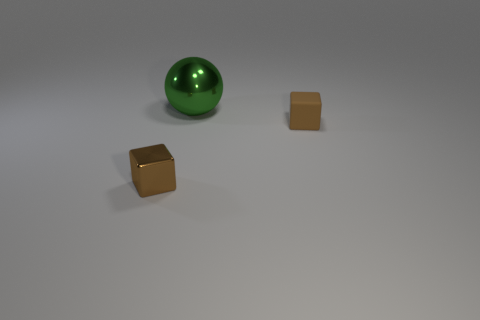Add 1 small rubber blocks. How many objects exist? 4 Subtract all cubes. How many objects are left? 1 Add 2 tiny yellow matte things. How many tiny yellow matte things exist? 2 Subtract 0 cyan cylinders. How many objects are left? 3 Subtract all tiny green balls. Subtract all tiny shiny objects. How many objects are left? 2 Add 2 big green metallic things. How many big green metallic things are left? 3 